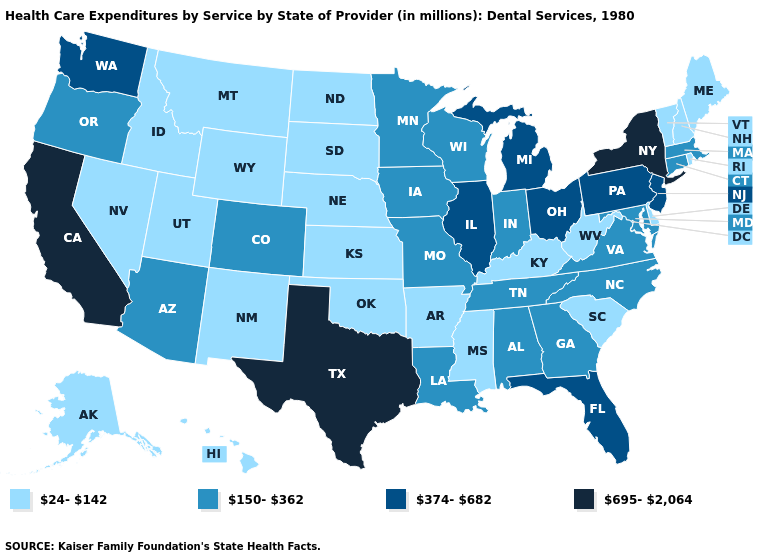What is the highest value in the West ?
Answer briefly. 695-2,064. Does North Carolina have a lower value than Georgia?
Short answer required. No. How many symbols are there in the legend?
Quick response, please. 4. What is the highest value in the Northeast ?
Be succinct. 695-2,064. What is the value of Utah?
Short answer required. 24-142. What is the value of Oklahoma?
Answer briefly. 24-142. What is the value of Alabama?
Give a very brief answer. 150-362. What is the value of Indiana?
Be succinct. 150-362. Which states hav the highest value in the Northeast?
Quick response, please. New York. Name the states that have a value in the range 374-682?
Write a very short answer. Florida, Illinois, Michigan, New Jersey, Ohio, Pennsylvania, Washington. Name the states that have a value in the range 150-362?
Give a very brief answer. Alabama, Arizona, Colorado, Connecticut, Georgia, Indiana, Iowa, Louisiana, Maryland, Massachusetts, Minnesota, Missouri, North Carolina, Oregon, Tennessee, Virginia, Wisconsin. Does New York have the highest value in the Northeast?
Short answer required. Yes. Which states have the lowest value in the MidWest?
Keep it brief. Kansas, Nebraska, North Dakota, South Dakota. What is the value of Maine?
Quick response, please. 24-142. 